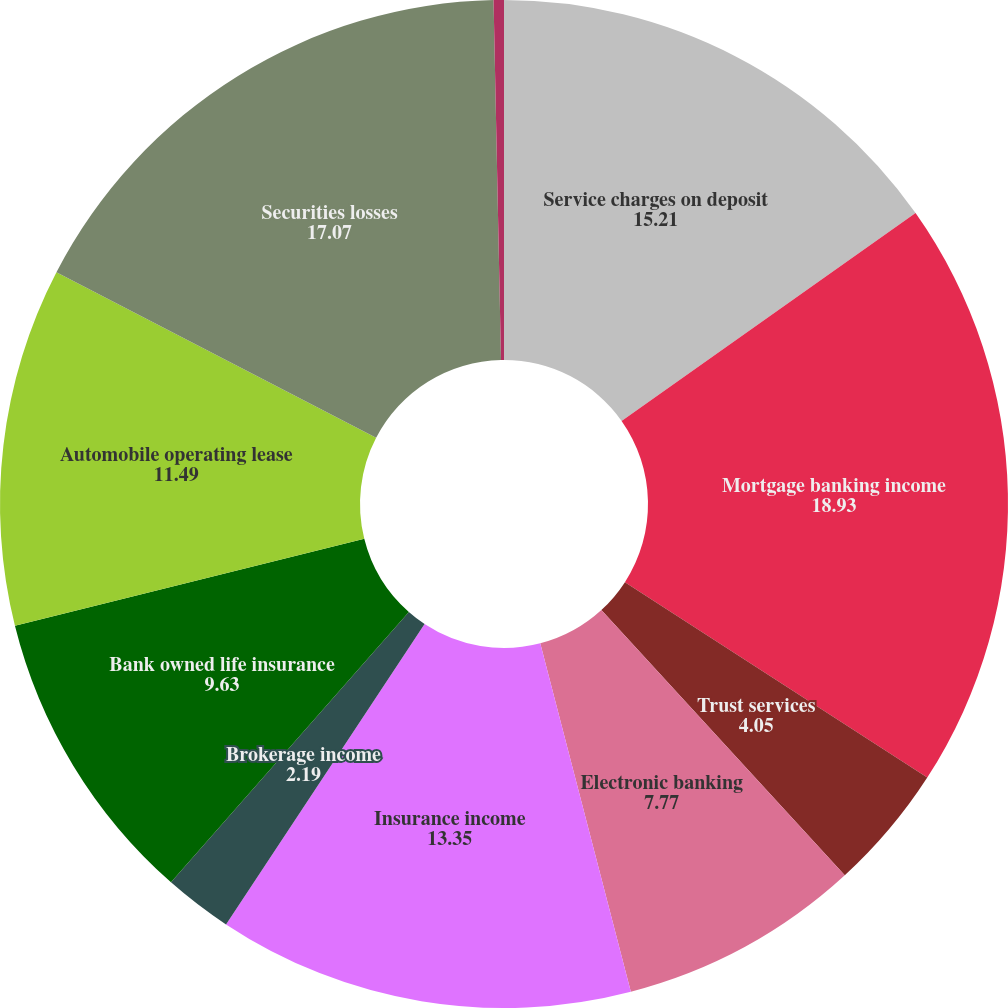Convert chart to OTSL. <chart><loc_0><loc_0><loc_500><loc_500><pie_chart><fcel>Service charges on deposit<fcel>Mortgage banking income<fcel>Trust services<fcel>Electronic banking<fcel>Insurance income<fcel>Brokerage income<fcel>Bank owned life insurance<fcel>Automobile operating lease<fcel>Securities losses<fcel>Other income<nl><fcel>15.21%<fcel>18.93%<fcel>4.05%<fcel>7.77%<fcel>13.35%<fcel>2.19%<fcel>9.63%<fcel>11.49%<fcel>17.07%<fcel>0.33%<nl></chart> 